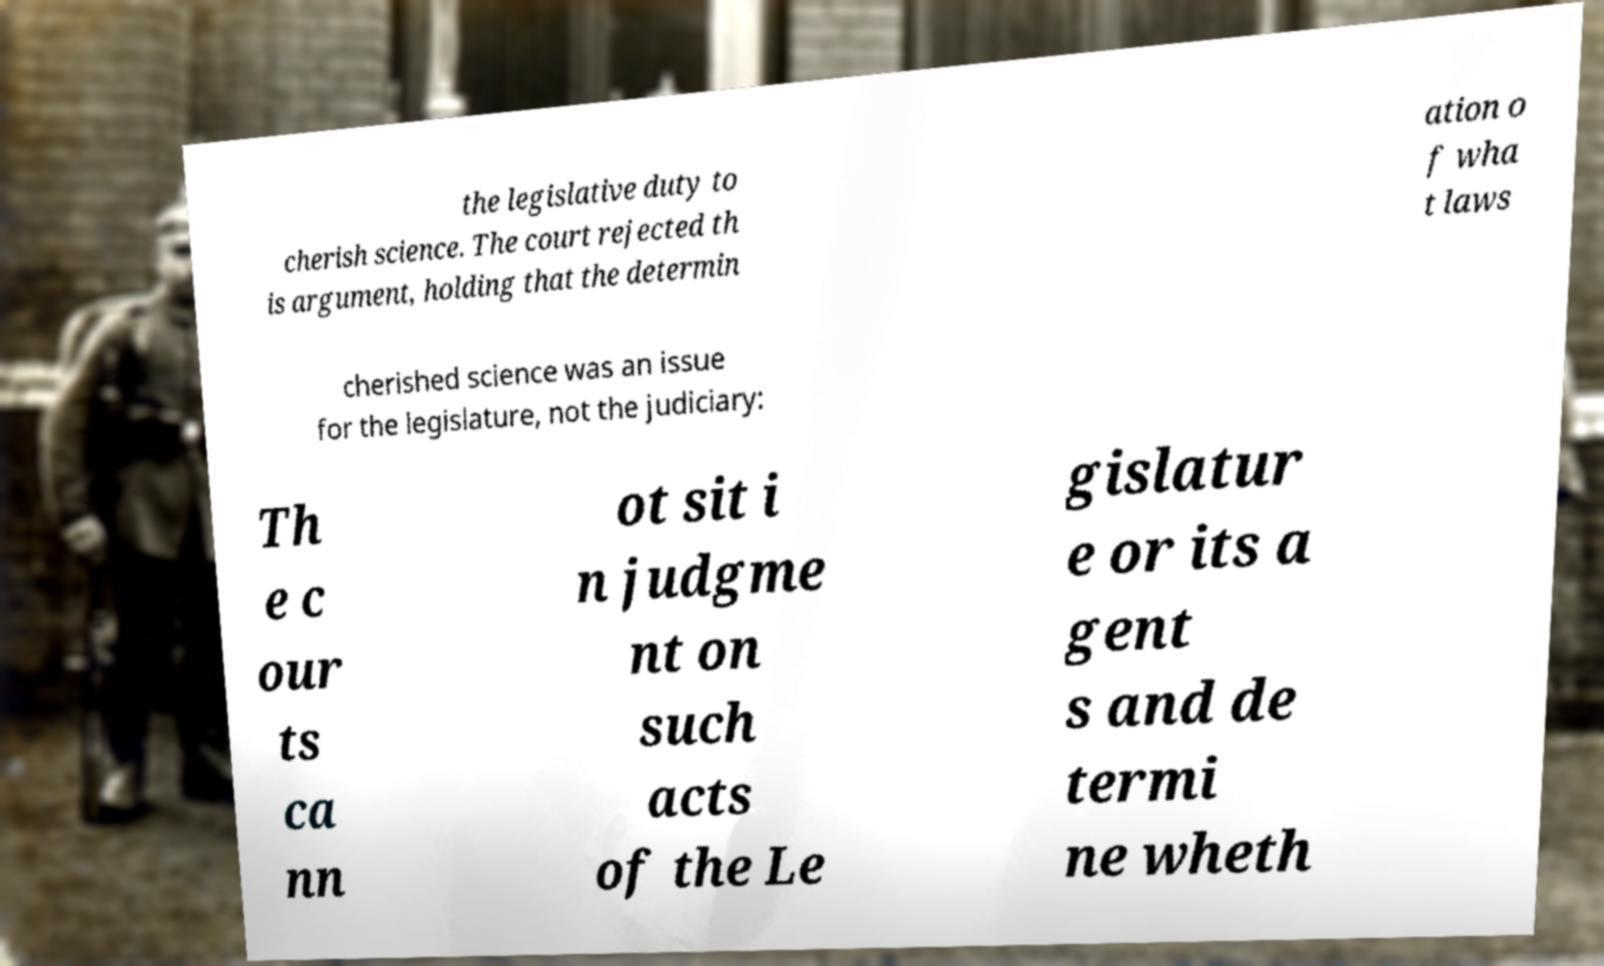For documentation purposes, I need the text within this image transcribed. Could you provide that? the legislative duty to cherish science. The court rejected th is argument, holding that the determin ation o f wha t laws cherished science was an issue for the legislature, not the judiciary: Th e c our ts ca nn ot sit i n judgme nt on such acts of the Le gislatur e or its a gent s and de termi ne wheth 